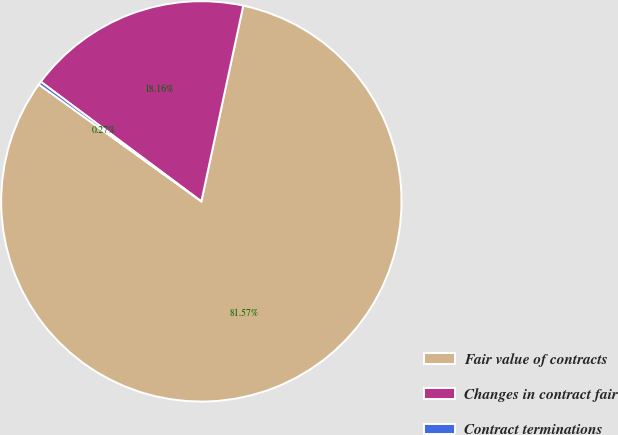Convert chart to OTSL. <chart><loc_0><loc_0><loc_500><loc_500><pie_chart><fcel>Fair value of contracts<fcel>Changes in contract fair<fcel>Contract terminations<nl><fcel>81.56%<fcel>18.16%<fcel>0.27%<nl></chart> 